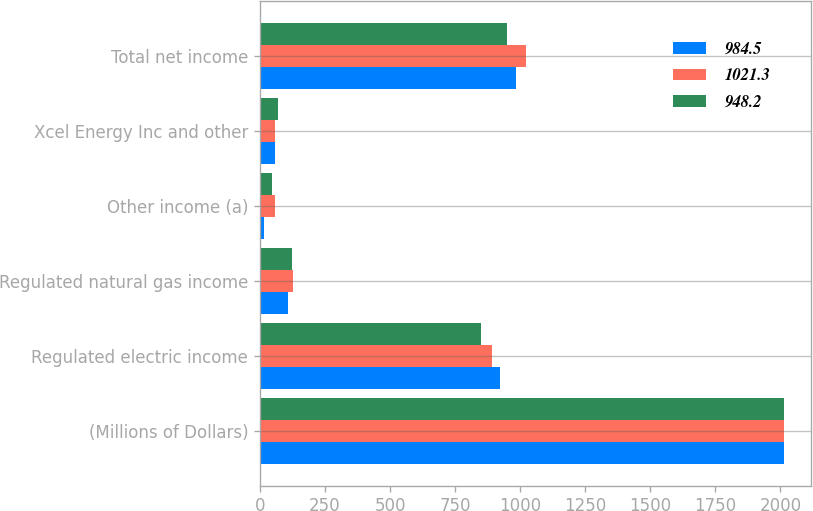<chart> <loc_0><loc_0><loc_500><loc_500><stacked_bar_chart><ecel><fcel>(Millions of Dollars)<fcel>Regulated electric income<fcel>Regulated natural gas income<fcel>Other income (a)<fcel>Xcel Energy Inc and other<fcel>Total net income<nl><fcel>984.5<fcel>2015<fcel>921.4<fcel>106<fcel>15.8<fcel>58.7<fcel>984.5<nl><fcel>1021.3<fcel>2014<fcel>890.5<fcel>128.6<fcel>59.5<fcel>57.3<fcel>1021.3<nl><fcel>948.2<fcel>2013<fcel>850.7<fcel>123.7<fcel>44.6<fcel>70.8<fcel>948.2<nl></chart> 